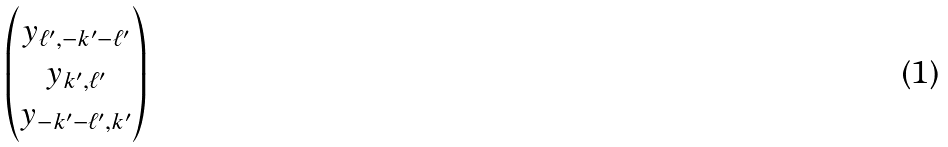Convert formula to latex. <formula><loc_0><loc_0><loc_500><loc_500>\begin{pmatrix} y _ { \ell ^ { \prime } , - k ^ { \prime } - \ell ^ { \prime } } \\ y _ { k ^ { \prime } , \ell ^ { \prime } } \\ y _ { - k ^ { \prime } - \ell ^ { \prime } , k ^ { \prime } } \\ \end{pmatrix}</formula> 